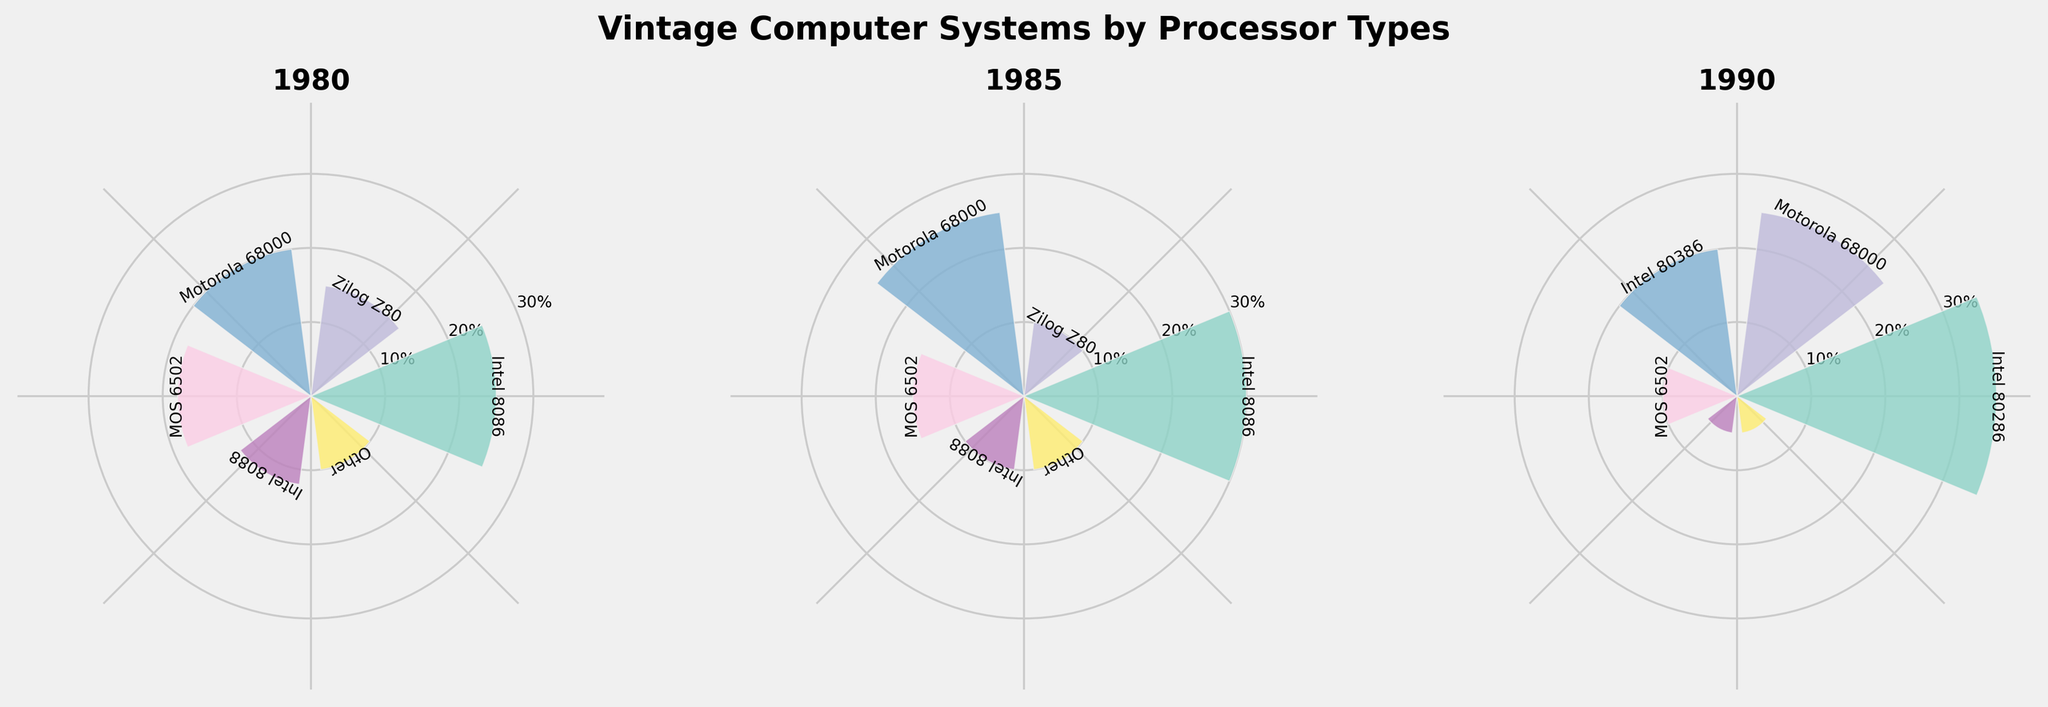What's the predominant processor type in 1980? To determine the predominant processor type in 1980, observe the rose chart for that year and identify the processor with the largest bar. The Intel 8086 has the largest bar indicating it holds 25% market share.
Answer: Intel 8086 How did the market share of Motorola 68000 change from 1980 to 1985? Compare the heights of the bars for Motorola 68000 between the 1980 and 1985 subplots. In 1980, the share is 20%, and in 1985, it is 25%.
Answer: Increased by 5% Which processor had the smallest market share in 1990? In the subplot for 1990, identify the processor with the smallest bar. Both Intel 8086 and "Other" have the smallest bars at 5%.
Answer: Intel 8086 and Other What is the total market share of Intel processors in 1990? Find the market shares of all Intel processors in 1990 (Intel 80286, Intel 80386, Intel 8086) and sum them: 35% + 20% + 5% = 60%.
Answer: 60% Which processor showed the highest growth in market share between 1980 and 1985? Compare the market shares of all processors between 1980 and 1985 and identify the processor with the most significant increase. Intel 8086 grew from 25% to 30%, a 5% increase.
Answer: Intel 8086 Compare the market share of MOS 6502 in 1980 and 1990. Did it increase or decrease? Look at the market share of MOS 6502 in 1980, which is 18%, and in 1990, which is 10%. The share decreased.
Answer: Decreased Which year had the most evenly distributed market share among processors? Look for the year where the bars in the rose chart are closest in height. In 1985, the distribution looks more even compared to the other years.
Answer: 1985 